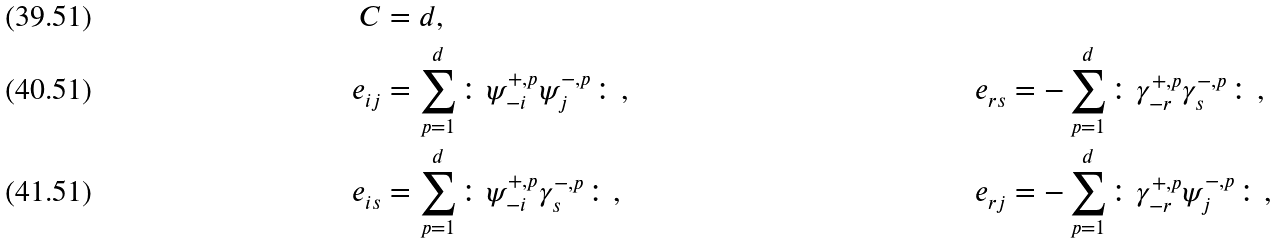Convert formula to latex. <formula><loc_0><loc_0><loc_500><loc_500>C & = d , \\ e _ { i j } & = \sum _ { p = 1 } ^ { d } \colon \psi ^ { + , p } _ { - i } \psi ^ { - , p } _ { j } \colon , & e _ { r s } & = - \sum _ { p = 1 } ^ { d } \colon \gamma ^ { + , p } _ { - r } \gamma ^ { - , p } _ { s } \colon , \\ e _ { i s } & = \sum _ { p = 1 } ^ { d } \colon \psi ^ { + , p } _ { - i } \gamma ^ { - , p } _ { s } \colon , & e _ { r j } & = - \sum _ { p = 1 } ^ { d } \colon \gamma ^ { + , p } _ { - r } \psi ^ { - , p } _ { j } \colon ,</formula> 